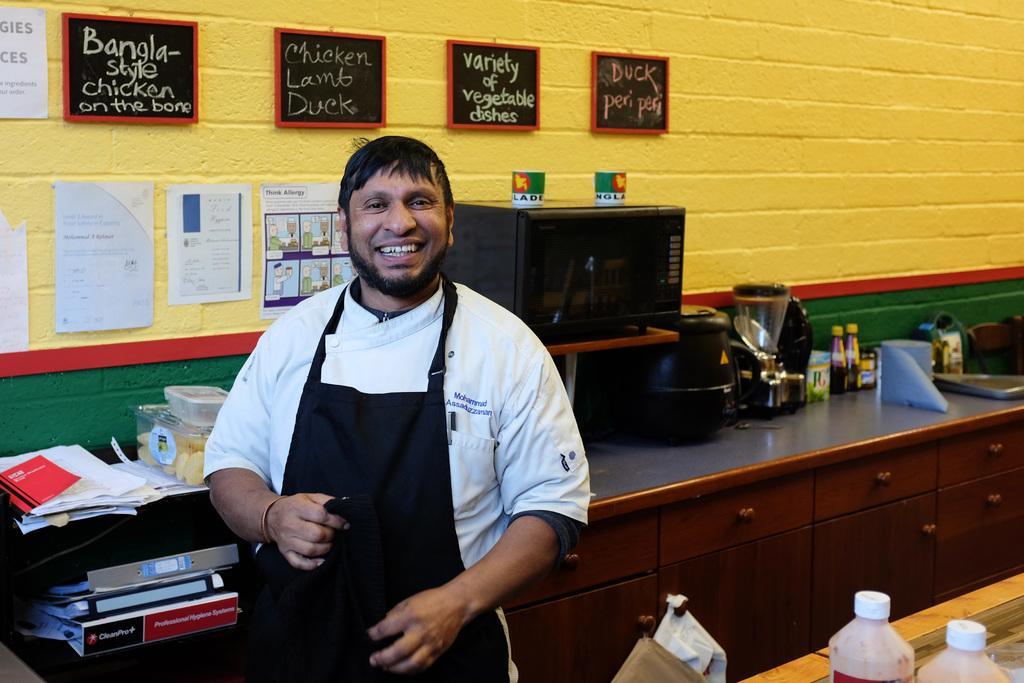How would you summarize this image in a sentence or two? In this image, we can see a person is smiling and seeing. He is holding some object and wearing an apron. Background we can see cupboards, kitchen platform, few machines, bottles, containers, files, papers, some objects. At the bottom, we can see few bottles with lid. Here there is a wall with posters and boards. 